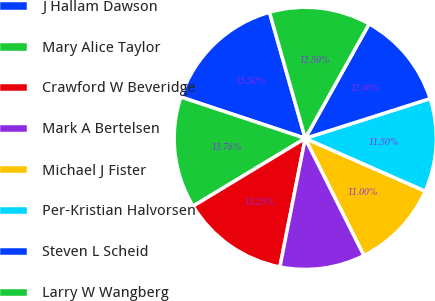Convert chart. <chart><loc_0><loc_0><loc_500><loc_500><pie_chart><fcel>J Hallam Dawson<fcel>Mary Alice Taylor<fcel>Crawford W Beveridge<fcel>Mark A Bertelsen<fcel>Michael J Fister<fcel>Per-Kristian Halvorsen<fcel>Steven L Scheid<fcel>Larry W Wangberg<nl><fcel>15.5%<fcel>13.76%<fcel>13.25%<fcel>10.5%<fcel>11.0%<fcel>11.5%<fcel>12.0%<fcel>12.5%<nl></chart> 